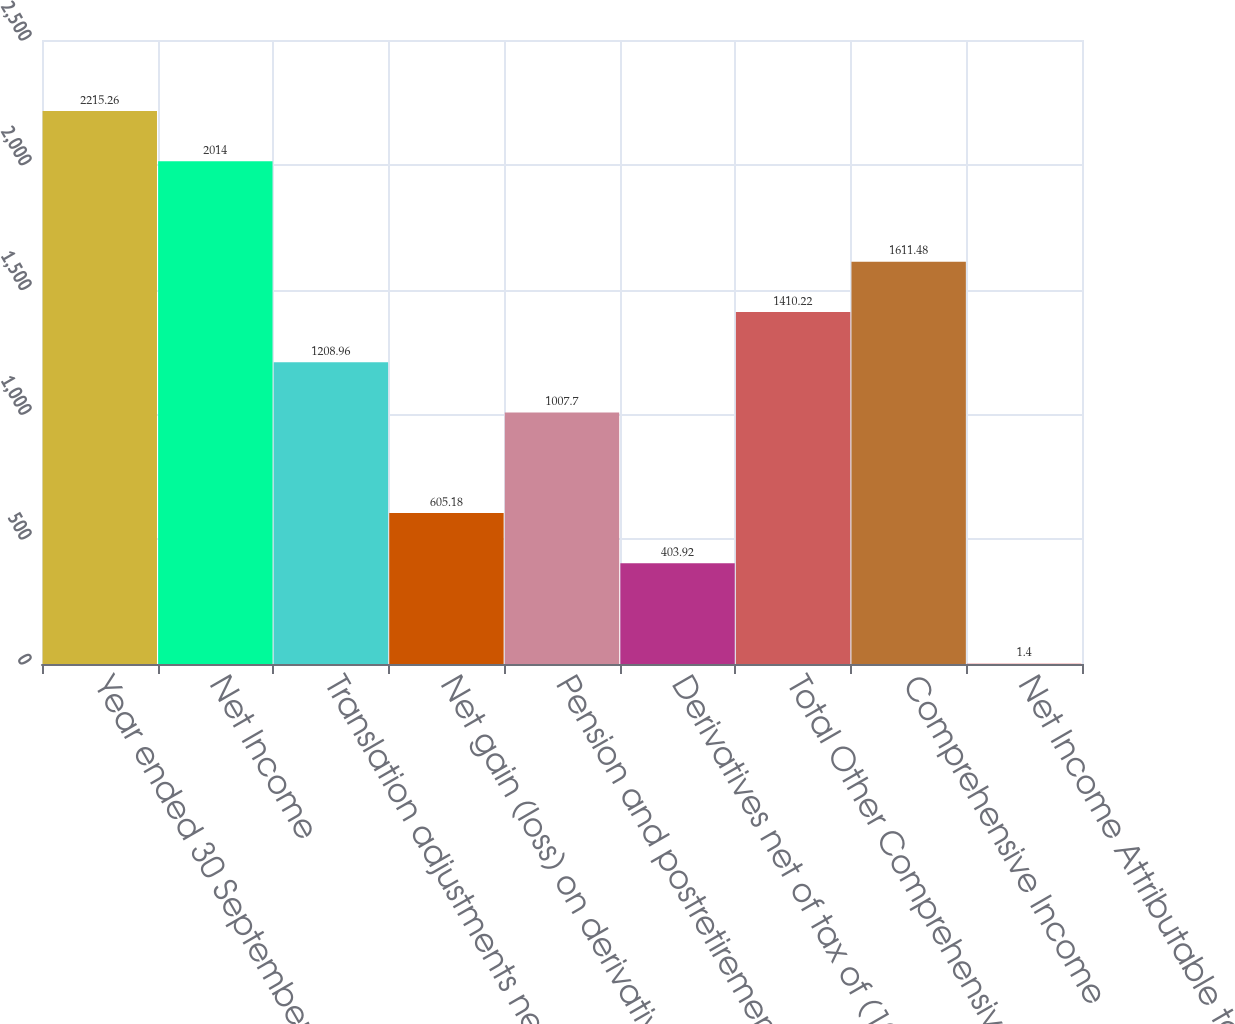Convert chart. <chart><loc_0><loc_0><loc_500><loc_500><bar_chart><fcel>Year ended 30 September<fcel>Net Income<fcel>Translation adjustments net of<fcel>Net gain (loss) on derivatives<fcel>Pension and postretirement<fcel>Derivatives net of tax of (19)<fcel>Total Other Comprehensive<fcel>Comprehensive Income<fcel>Net Income Attributable to<nl><fcel>2215.26<fcel>2014<fcel>1208.96<fcel>605.18<fcel>1007.7<fcel>403.92<fcel>1410.22<fcel>1611.48<fcel>1.4<nl></chart> 